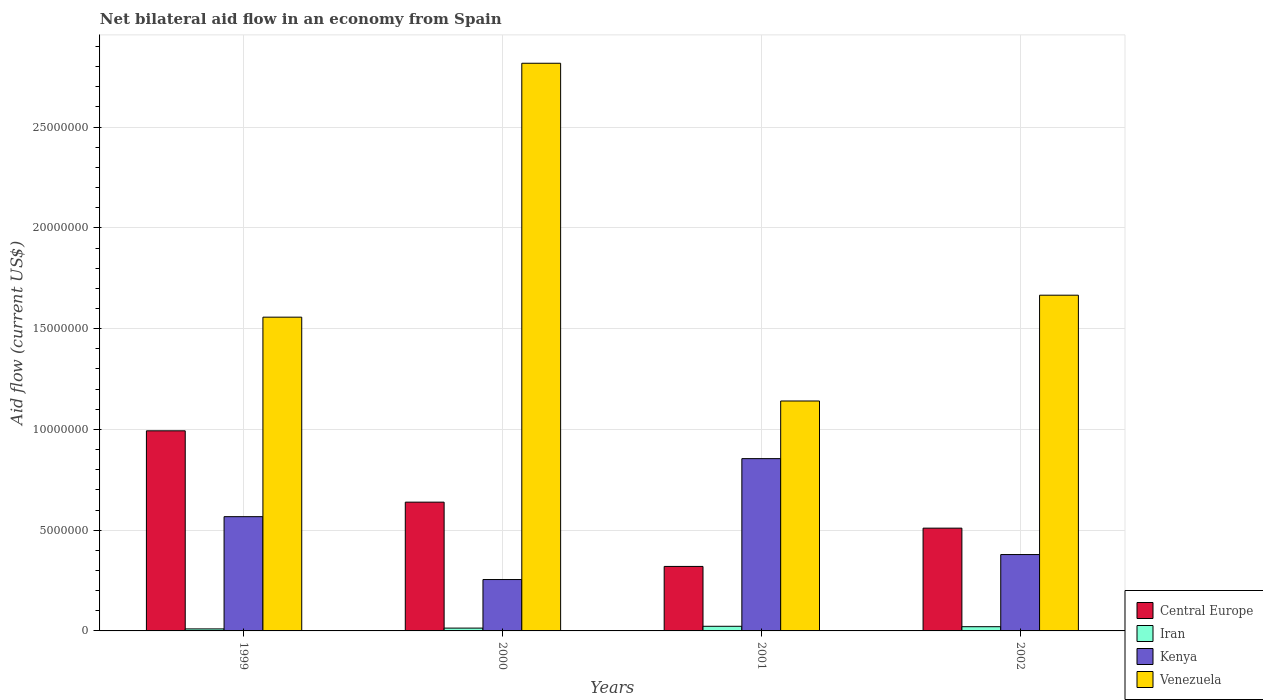How many different coloured bars are there?
Make the answer very short. 4. How many groups of bars are there?
Provide a succinct answer. 4. Are the number of bars on each tick of the X-axis equal?
Your response must be concise. Yes. What is the label of the 3rd group of bars from the left?
Keep it short and to the point. 2001. What is the net bilateral aid flow in Iran in 2001?
Your response must be concise. 2.30e+05. In which year was the net bilateral aid flow in Iran maximum?
Keep it short and to the point. 2001. In which year was the net bilateral aid flow in Venezuela minimum?
Offer a very short reply. 2001. What is the total net bilateral aid flow in Kenya in the graph?
Offer a terse response. 2.06e+07. What is the difference between the net bilateral aid flow in Kenya in 2000 and that in 2001?
Keep it short and to the point. -6.00e+06. What is the difference between the net bilateral aid flow in Venezuela in 2000 and the net bilateral aid flow in Kenya in 2001?
Keep it short and to the point. 1.96e+07. What is the average net bilateral aid flow in Central Europe per year?
Make the answer very short. 6.16e+06. In the year 2001, what is the difference between the net bilateral aid flow in Iran and net bilateral aid flow in Kenya?
Your answer should be very brief. -8.32e+06. In how many years, is the net bilateral aid flow in Iran greater than 10000000 US$?
Your response must be concise. 0. What is the ratio of the net bilateral aid flow in Kenya in 1999 to that in 2000?
Your answer should be compact. 2.22. Is the net bilateral aid flow in Iran in 1999 less than that in 2000?
Keep it short and to the point. Yes. Is the difference between the net bilateral aid flow in Iran in 2000 and 2001 greater than the difference between the net bilateral aid flow in Kenya in 2000 and 2001?
Your answer should be compact. Yes. What is the difference between the highest and the second highest net bilateral aid flow in Central Europe?
Provide a short and direct response. 3.54e+06. What is the difference between the highest and the lowest net bilateral aid flow in Central Europe?
Offer a very short reply. 6.73e+06. Is the sum of the net bilateral aid flow in Kenya in 2001 and 2002 greater than the maximum net bilateral aid flow in Central Europe across all years?
Offer a terse response. Yes. Is it the case that in every year, the sum of the net bilateral aid flow in Central Europe and net bilateral aid flow in Kenya is greater than the sum of net bilateral aid flow in Iran and net bilateral aid flow in Venezuela?
Keep it short and to the point. No. What does the 2nd bar from the left in 1999 represents?
Ensure brevity in your answer.  Iran. What does the 3rd bar from the right in 2001 represents?
Provide a succinct answer. Iran. How many bars are there?
Your response must be concise. 16. How many years are there in the graph?
Your response must be concise. 4. Does the graph contain any zero values?
Your answer should be compact. No. How are the legend labels stacked?
Offer a terse response. Vertical. What is the title of the graph?
Ensure brevity in your answer.  Net bilateral aid flow in an economy from Spain. Does "Macao" appear as one of the legend labels in the graph?
Offer a terse response. No. What is the Aid flow (current US$) in Central Europe in 1999?
Ensure brevity in your answer.  9.93e+06. What is the Aid flow (current US$) in Kenya in 1999?
Ensure brevity in your answer.  5.67e+06. What is the Aid flow (current US$) of Venezuela in 1999?
Offer a terse response. 1.56e+07. What is the Aid flow (current US$) of Central Europe in 2000?
Make the answer very short. 6.39e+06. What is the Aid flow (current US$) of Iran in 2000?
Give a very brief answer. 1.40e+05. What is the Aid flow (current US$) of Kenya in 2000?
Keep it short and to the point. 2.55e+06. What is the Aid flow (current US$) in Venezuela in 2000?
Keep it short and to the point. 2.82e+07. What is the Aid flow (current US$) in Central Europe in 2001?
Your answer should be compact. 3.20e+06. What is the Aid flow (current US$) in Kenya in 2001?
Your response must be concise. 8.55e+06. What is the Aid flow (current US$) of Venezuela in 2001?
Give a very brief answer. 1.14e+07. What is the Aid flow (current US$) of Central Europe in 2002?
Offer a terse response. 5.10e+06. What is the Aid flow (current US$) of Kenya in 2002?
Provide a short and direct response. 3.79e+06. What is the Aid flow (current US$) of Venezuela in 2002?
Provide a short and direct response. 1.67e+07. Across all years, what is the maximum Aid flow (current US$) in Central Europe?
Offer a terse response. 9.93e+06. Across all years, what is the maximum Aid flow (current US$) of Kenya?
Provide a short and direct response. 8.55e+06. Across all years, what is the maximum Aid flow (current US$) in Venezuela?
Give a very brief answer. 2.82e+07. Across all years, what is the minimum Aid flow (current US$) in Central Europe?
Provide a short and direct response. 3.20e+06. Across all years, what is the minimum Aid flow (current US$) of Iran?
Your response must be concise. 1.00e+05. Across all years, what is the minimum Aid flow (current US$) of Kenya?
Provide a short and direct response. 2.55e+06. Across all years, what is the minimum Aid flow (current US$) of Venezuela?
Provide a short and direct response. 1.14e+07. What is the total Aid flow (current US$) in Central Europe in the graph?
Ensure brevity in your answer.  2.46e+07. What is the total Aid flow (current US$) of Iran in the graph?
Provide a short and direct response. 6.80e+05. What is the total Aid flow (current US$) of Kenya in the graph?
Provide a succinct answer. 2.06e+07. What is the total Aid flow (current US$) of Venezuela in the graph?
Offer a terse response. 7.18e+07. What is the difference between the Aid flow (current US$) in Central Europe in 1999 and that in 2000?
Give a very brief answer. 3.54e+06. What is the difference between the Aid flow (current US$) in Iran in 1999 and that in 2000?
Provide a short and direct response. -4.00e+04. What is the difference between the Aid flow (current US$) of Kenya in 1999 and that in 2000?
Make the answer very short. 3.12e+06. What is the difference between the Aid flow (current US$) of Venezuela in 1999 and that in 2000?
Your answer should be very brief. -1.26e+07. What is the difference between the Aid flow (current US$) of Central Europe in 1999 and that in 2001?
Your answer should be very brief. 6.73e+06. What is the difference between the Aid flow (current US$) in Iran in 1999 and that in 2001?
Offer a terse response. -1.30e+05. What is the difference between the Aid flow (current US$) of Kenya in 1999 and that in 2001?
Provide a short and direct response. -2.88e+06. What is the difference between the Aid flow (current US$) in Venezuela in 1999 and that in 2001?
Provide a succinct answer. 4.16e+06. What is the difference between the Aid flow (current US$) in Central Europe in 1999 and that in 2002?
Give a very brief answer. 4.83e+06. What is the difference between the Aid flow (current US$) in Iran in 1999 and that in 2002?
Give a very brief answer. -1.10e+05. What is the difference between the Aid flow (current US$) in Kenya in 1999 and that in 2002?
Provide a short and direct response. 1.88e+06. What is the difference between the Aid flow (current US$) in Venezuela in 1999 and that in 2002?
Your answer should be compact. -1.09e+06. What is the difference between the Aid flow (current US$) in Central Europe in 2000 and that in 2001?
Make the answer very short. 3.19e+06. What is the difference between the Aid flow (current US$) in Iran in 2000 and that in 2001?
Make the answer very short. -9.00e+04. What is the difference between the Aid flow (current US$) of Kenya in 2000 and that in 2001?
Ensure brevity in your answer.  -6.00e+06. What is the difference between the Aid flow (current US$) of Venezuela in 2000 and that in 2001?
Provide a short and direct response. 1.68e+07. What is the difference between the Aid flow (current US$) in Central Europe in 2000 and that in 2002?
Provide a short and direct response. 1.29e+06. What is the difference between the Aid flow (current US$) of Kenya in 2000 and that in 2002?
Make the answer very short. -1.24e+06. What is the difference between the Aid flow (current US$) of Venezuela in 2000 and that in 2002?
Your answer should be compact. 1.15e+07. What is the difference between the Aid flow (current US$) in Central Europe in 2001 and that in 2002?
Provide a succinct answer. -1.90e+06. What is the difference between the Aid flow (current US$) of Kenya in 2001 and that in 2002?
Provide a succinct answer. 4.76e+06. What is the difference between the Aid flow (current US$) of Venezuela in 2001 and that in 2002?
Offer a terse response. -5.25e+06. What is the difference between the Aid flow (current US$) of Central Europe in 1999 and the Aid flow (current US$) of Iran in 2000?
Offer a terse response. 9.79e+06. What is the difference between the Aid flow (current US$) of Central Europe in 1999 and the Aid flow (current US$) of Kenya in 2000?
Ensure brevity in your answer.  7.38e+06. What is the difference between the Aid flow (current US$) in Central Europe in 1999 and the Aid flow (current US$) in Venezuela in 2000?
Offer a terse response. -1.82e+07. What is the difference between the Aid flow (current US$) of Iran in 1999 and the Aid flow (current US$) of Kenya in 2000?
Offer a very short reply. -2.45e+06. What is the difference between the Aid flow (current US$) in Iran in 1999 and the Aid flow (current US$) in Venezuela in 2000?
Provide a succinct answer. -2.81e+07. What is the difference between the Aid flow (current US$) of Kenya in 1999 and the Aid flow (current US$) of Venezuela in 2000?
Your response must be concise. -2.25e+07. What is the difference between the Aid flow (current US$) of Central Europe in 1999 and the Aid flow (current US$) of Iran in 2001?
Your answer should be compact. 9.70e+06. What is the difference between the Aid flow (current US$) of Central Europe in 1999 and the Aid flow (current US$) of Kenya in 2001?
Your answer should be very brief. 1.38e+06. What is the difference between the Aid flow (current US$) in Central Europe in 1999 and the Aid flow (current US$) in Venezuela in 2001?
Provide a succinct answer. -1.48e+06. What is the difference between the Aid flow (current US$) in Iran in 1999 and the Aid flow (current US$) in Kenya in 2001?
Ensure brevity in your answer.  -8.45e+06. What is the difference between the Aid flow (current US$) of Iran in 1999 and the Aid flow (current US$) of Venezuela in 2001?
Your response must be concise. -1.13e+07. What is the difference between the Aid flow (current US$) of Kenya in 1999 and the Aid flow (current US$) of Venezuela in 2001?
Provide a short and direct response. -5.74e+06. What is the difference between the Aid flow (current US$) in Central Europe in 1999 and the Aid flow (current US$) in Iran in 2002?
Ensure brevity in your answer.  9.72e+06. What is the difference between the Aid flow (current US$) of Central Europe in 1999 and the Aid flow (current US$) of Kenya in 2002?
Make the answer very short. 6.14e+06. What is the difference between the Aid flow (current US$) of Central Europe in 1999 and the Aid flow (current US$) of Venezuela in 2002?
Give a very brief answer. -6.73e+06. What is the difference between the Aid flow (current US$) of Iran in 1999 and the Aid flow (current US$) of Kenya in 2002?
Provide a short and direct response. -3.69e+06. What is the difference between the Aid flow (current US$) of Iran in 1999 and the Aid flow (current US$) of Venezuela in 2002?
Your answer should be compact. -1.66e+07. What is the difference between the Aid flow (current US$) in Kenya in 1999 and the Aid flow (current US$) in Venezuela in 2002?
Offer a terse response. -1.10e+07. What is the difference between the Aid flow (current US$) in Central Europe in 2000 and the Aid flow (current US$) in Iran in 2001?
Provide a short and direct response. 6.16e+06. What is the difference between the Aid flow (current US$) in Central Europe in 2000 and the Aid flow (current US$) in Kenya in 2001?
Ensure brevity in your answer.  -2.16e+06. What is the difference between the Aid flow (current US$) of Central Europe in 2000 and the Aid flow (current US$) of Venezuela in 2001?
Make the answer very short. -5.02e+06. What is the difference between the Aid flow (current US$) in Iran in 2000 and the Aid flow (current US$) in Kenya in 2001?
Provide a succinct answer. -8.41e+06. What is the difference between the Aid flow (current US$) in Iran in 2000 and the Aid flow (current US$) in Venezuela in 2001?
Offer a terse response. -1.13e+07. What is the difference between the Aid flow (current US$) of Kenya in 2000 and the Aid flow (current US$) of Venezuela in 2001?
Your response must be concise. -8.86e+06. What is the difference between the Aid flow (current US$) of Central Europe in 2000 and the Aid flow (current US$) of Iran in 2002?
Offer a very short reply. 6.18e+06. What is the difference between the Aid flow (current US$) in Central Europe in 2000 and the Aid flow (current US$) in Kenya in 2002?
Offer a very short reply. 2.60e+06. What is the difference between the Aid flow (current US$) in Central Europe in 2000 and the Aid flow (current US$) in Venezuela in 2002?
Your response must be concise. -1.03e+07. What is the difference between the Aid flow (current US$) of Iran in 2000 and the Aid flow (current US$) of Kenya in 2002?
Offer a very short reply. -3.65e+06. What is the difference between the Aid flow (current US$) in Iran in 2000 and the Aid flow (current US$) in Venezuela in 2002?
Keep it short and to the point. -1.65e+07. What is the difference between the Aid flow (current US$) in Kenya in 2000 and the Aid flow (current US$) in Venezuela in 2002?
Your answer should be very brief. -1.41e+07. What is the difference between the Aid flow (current US$) of Central Europe in 2001 and the Aid flow (current US$) of Iran in 2002?
Ensure brevity in your answer.  2.99e+06. What is the difference between the Aid flow (current US$) of Central Europe in 2001 and the Aid flow (current US$) of Kenya in 2002?
Make the answer very short. -5.90e+05. What is the difference between the Aid flow (current US$) of Central Europe in 2001 and the Aid flow (current US$) of Venezuela in 2002?
Your answer should be very brief. -1.35e+07. What is the difference between the Aid flow (current US$) in Iran in 2001 and the Aid flow (current US$) in Kenya in 2002?
Your answer should be compact. -3.56e+06. What is the difference between the Aid flow (current US$) in Iran in 2001 and the Aid flow (current US$) in Venezuela in 2002?
Ensure brevity in your answer.  -1.64e+07. What is the difference between the Aid flow (current US$) of Kenya in 2001 and the Aid flow (current US$) of Venezuela in 2002?
Keep it short and to the point. -8.11e+06. What is the average Aid flow (current US$) in Central Europe per year?
Give a very brief answer. 6.16e+06. What is the average Aid flow (current US$) of Iran per year?
Provide a short and direct response. 1.70e+05. What is the average Aid flow (current US$) of Kenya per year?
Give a very brief answer. 5.14e+06. What is the average Aid flow (current US$) of Venezuela per year?
Offer a very short reply. 1.80e+07. In the year 1999, what is the difference between the Aid flow (current US$) in Central Europe and Aid flow (current US$) in Iran?
Your answer should be compact. 9.83e+06. In the year 1999, what is the difference between the Aid flow (current US$) of Central Europe and Aid flow (current US$) of Kenya?
Offer a terse response. 4.26e+06. In the year 1999, what is the difference between the Aid flow (current US$) in Central Europe and Aid flow (current US$) in Venezuela?
Ensure brevity in your answer.  -5.64e+06. In the year 1999, what is the difference between the Aid flow (current US$) in Iran and Aid flow (current US$) in Kenya?
Your answer should be compact. -5.57e+06. In the year 1999, what is the difference between the Aid flow (current US$) in Iran and Aid flow (current US$) in Venezuela?
Provide a short and direct response. -1.55e+07. In the year 1999, what is the difference between the Aid flow (current US$) of Kenya and Aid flow (current US$) of Venezuela?
Keep it short and to the point. -9.90e+06. In the year 2000, what is the difference between the Aid flow (current US$) in Central Europe and Aid flow (current US$) in Iran?
Give a very brief answer. 6.25e+06. In the year 2000, what is the difference between the Aid flow (current US$) in Central Europe and Aid flow (current US$) in Kenya?
Your answer should be compact. 3.84e+06. In the year 2000, what is the difference between the Aid flow (current US$) in Central Europe and Aid flow (current US$) in Venezuela?
Ensure brevity in your answer.  -2.18e+07. In the year 2000, what is the difference between the Aid flow (current US$) of Iran and Aid flow (current US$) of Kenya?
Ensure brevity in your answer.  -2.41e+06. In the year 2000, what is the difference between the Aid flow (current US$) in Iran and Aid flow (current US$) in Venezuela?
Your answer should be compact. -2.80e+07. In the year 2000, what is the difference between the Aid flow (current US$) of Kenya and Aid flow (current US$) of Venezuela?
Give a very brief answer. -2.56e+07. In the year 2001, what is the difference between the Aid flow (current US$) of Central Europe and Aid flow (current US$) of Iran?
Give a very brief answer. 2.97e+06. In the year 2001, what is the difference between the Aid flow (current US$) of Central Europe and Aid flow (current US$) of Kenya?
Make the answer very short. -5.35e+06. In the year 2001, what is the difference between the Aid flow (current US$) of Central Europe and Aid flow (current US$) of Venezuela?
Your answer should be very brief. -8.21e+06. In the year 2001, what is the difference between the Aid flow (current US$) of Iran and Aid flow (current US$) of Kenya?
Offer a terse response. -8.32e+06. In the year 2001, what is the difference between the Aid flow (current US$) in Iran and Aid flow (current US$) in Venezuela?
Your answer should be very brief. -1.12e+07. In the year 2001, what is the difference between the Aid flow (current US$) in Kenya and Aid flow (current US$) in Venezuela?
Your answer should be compact. -2.86e+06. In the year 2002, what is the difference between the Aid flow (current US$) of Central Europe and Aid flow (current US$) of Iran?
Offer a very short reply. 4.89e+06. In the year 2002, what is the difference between the Aid flow (current US$) in Central Europe and Aid flow (current US$) in Kenya?
Give a very brief answer. 1.31e+06. In the year 2002, what is the difference between the Aid flow (current US$) of Central Europe and Aid flow (current US$) of Venezuela?
Make the answer very short. -1.16e+07. In the year 2002, what is the difference between the Aid flow (current US$) of Iran and Aid flow (current US$) of Kenya?
Give a very brief answer. -3.58e+06. In the year 2002, what is the difference between the Aid flow (current US$) in Iran and Aid flow (current US$) in Venezuela?
Offer a terse response. -1.64e+07. In the year 2002, what is the difference between the Aid flow (current US$) in Kenya and Aid flow (current US$) in Venezuela?
Provide a succinct answer. -1.29e+07. What is the ratio of the Aid flow (current US$) in Central Europe in 1999 to that in 2000?
Give a very brief answer. 1.55. What is the ratio of the Aid flow (current US$) of Kenya in 1999 to that in 2000?
Ensure brevity in your answer.  2.22. What is the ratio of the Aid flow (current US$) in Venezuela in 1999 to that in 2000?
Provide a succinct answer. 0.55. What is the ratio of the Aid flow (current US$) in Central Europe in 1999 to that in 2001?
Keep it short and to the point. 3.1. What is the ratio of the Aid flow (current US$) of Iran in 1999 to that in 2001?
Provide a succinct answer. 0.43. What is the ratio of the Aid flow (current US$) of Kenya in 1999 to that in 2001?
Ensure brevity in your answer.  0.66. What is the ratio of the Aid flow (current US$) of Venezuela in 1999 to that in 2001?
Provide a succinct answer. 1.36. What is the ratio of the Aid flow (current US$) of Central Europe in 1999 to that in 2002?
Provide a short and direct response. 1.95. What is the ratio of the Aid flow (current US$) in Iran in 1999 to that in 2002?
Your answer should be very brief. 0.48. What is the ratio of the Aid flow (current US$) of Kenya in 1999 to that in 2002?
Your answer should be very brief. 1.5. What is the ratio of the Aid flow (current US$) in Venezuela in 1999 to that in 2002?
Give a very brief answer. 0.93. What is the ratio of the Aid flow (current US$) in Central Europe in 2000 to that in 2001?
Your answer should be very brief. 2. What is the ratio of the Aid flow (current US$) in Iran in 2000 to that in 2001?
Your response must be concise. 0.61. What is the ratio of the Aid flow (current US$) of Kenya in 2000 to that in 2001?
Provide a succinct answer. 0.3. What is the ratio of the Aid flow (current US$) of Venezuela in 2000 to that in 2001?
Ensure brevity in your answer.  2.47. What is the ratio of the Aid flow (current US$) of Central Europe in 2000 to that in 2002?
Your response must be concise. 1.25. What is the ratio of the Aid flow (current US$) of Iran in 2000 to that in 2002?
Provide a succinct answer. 0.67. What is the ratio of the Aid flow (current US$) in Kenya in 2000 to that in 2002?
Offer a terse response. 0.67. What is the ratio of the Aid flow (current US$) of Venezuela in 2000 to that in 2002?
Make the answer very short. 1.69. What is the ratio of the Aid flow (current US$) of Central Europe in 2001 to that in 2002?
Your response must be concise. 0.63. What is the ratio of the Aid flow (current US$) of Iran in 2001 to that in 2002?
Your answer should be very brief. 1.1. What is the ratio of the Aid flow (current US$) in Kenya in 2001 to that in 2002?
Give a very brief answer. 2.26. What is the ratio of the Aid flow (current US$) of Venezuela in 2001 to that in 2002?
Give a very brief answer. 0.68. What is the difference between the highest and the second highest Aid flow (current US$) in Central Europe?
Your answer should be compact. 3.54e+06. What is the difference between the highest and the second highest Aid flow (current US$) in Iran?
Your answer should be very brief. 2.00e+04. What is the difference between the highest and the second highest Aid flow (current US$) in Kenya?
Ensure brevity in your answer.  2.88e+06. What is the difference between the highest and the second highest Aid flow (current US$) of Venezuela?
Give a very brief answer. 1.15e+07. What is the difference between the highest and the lowest Aid flow (current US$) in Central Europe?
Your response must be concise. 6.73e+06. What is the difference between the highest and the lowest Aid flow (current US$) of Iran?
Provide a succinct answer. 1.30e+05. What is the difference between the highest and the lowest Aid flow (current US$) in Venezuela?
Make the answer very short. 1.68e+07. 